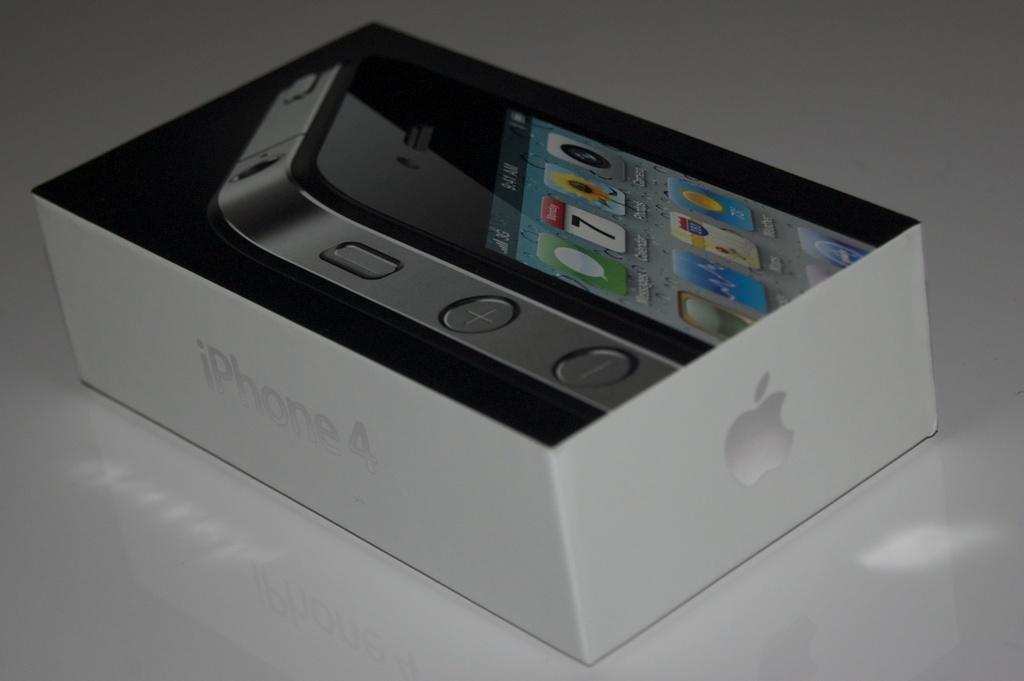Provide a one-sentence caption for the provided image. a white box with the word iPhone on the side. 